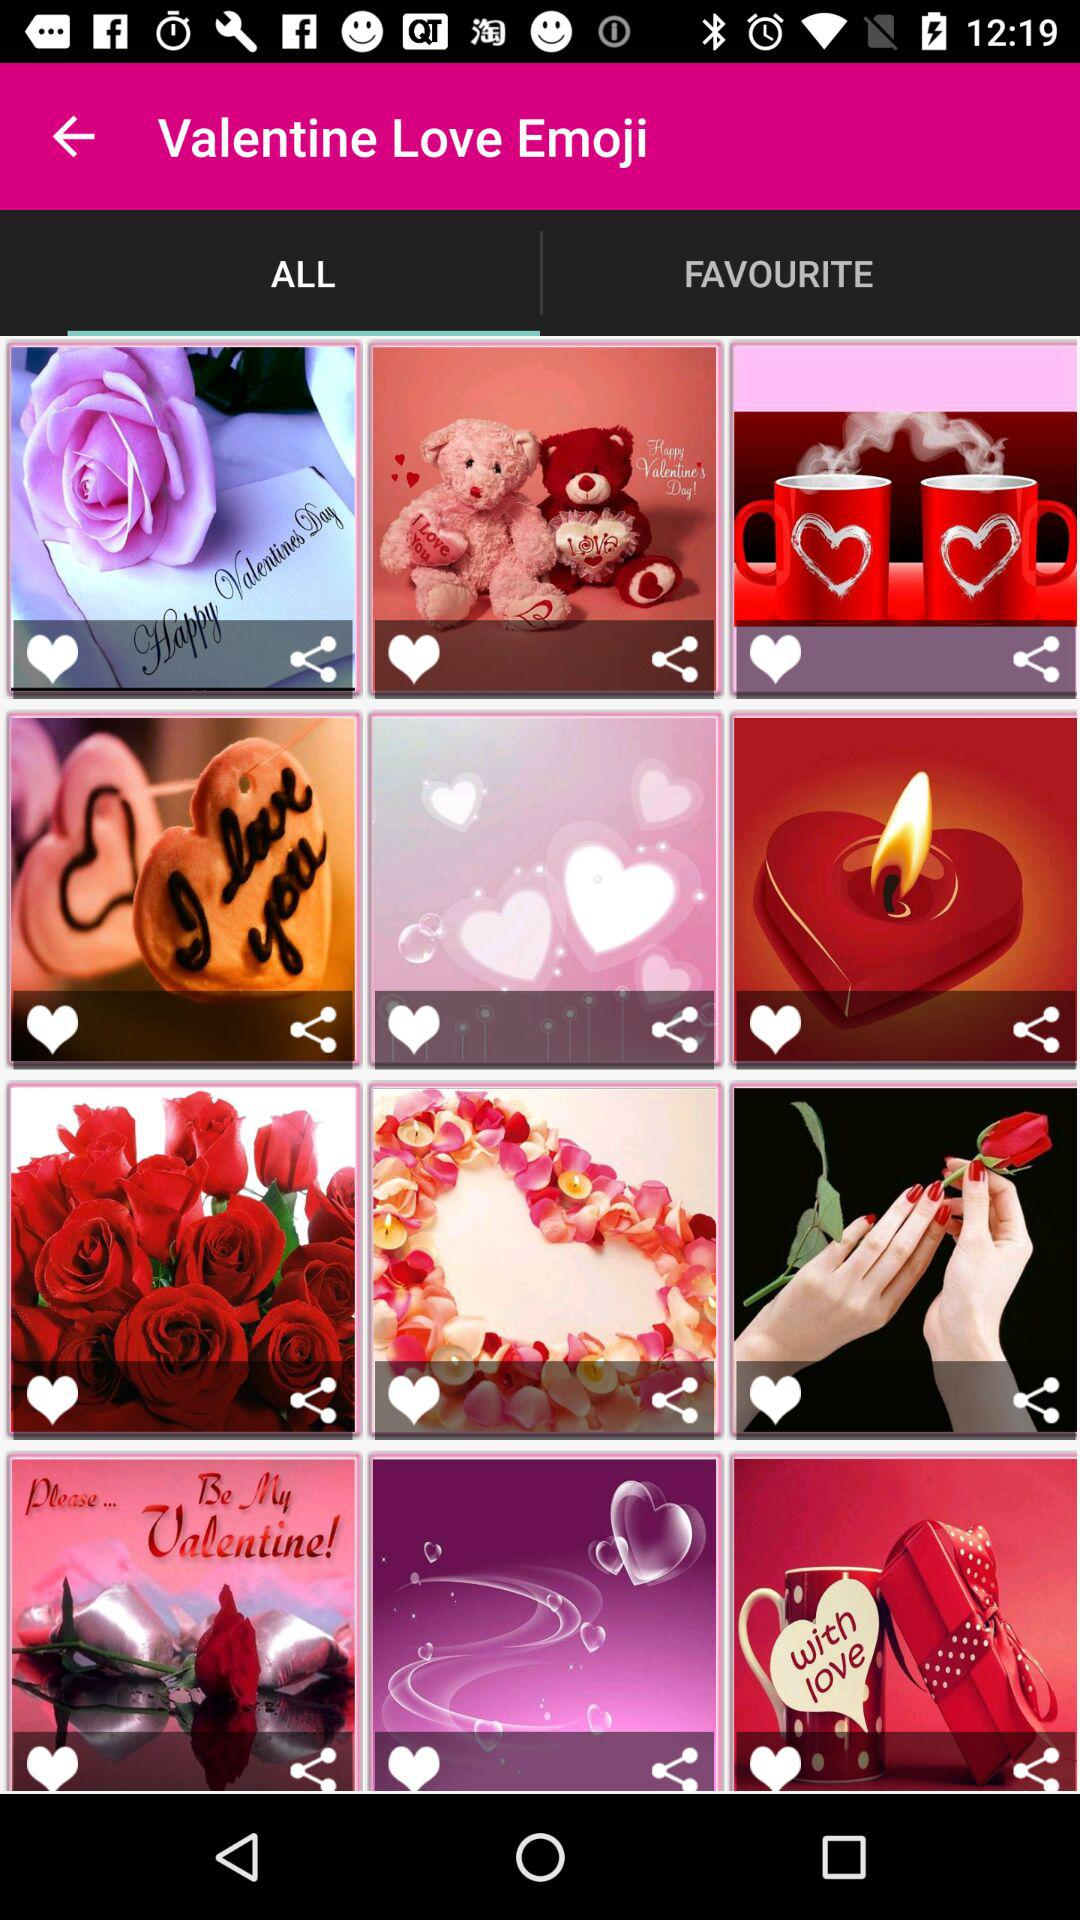What is the application name? The application name is "Valentine Love Emoji". 